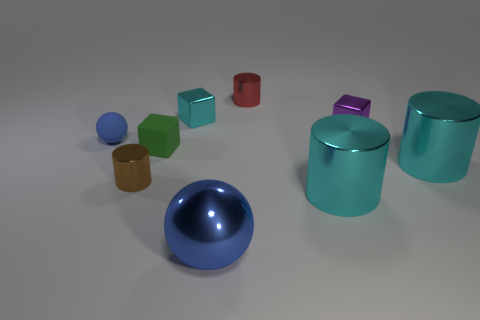Subtract all small brown cylinders. How many cylinders are left? 3 Subtract all cyan cylinders. How many cylinders are left? 2 Subtract all cylinders. How many objects are left? 5 Subtract 1 cylinders. How many cylinders are left? 3 Subtract all gray balls. Subtract all red blocks. How many balls are left? 2 Subtract all cyan spheres. How many red cylinders are left? 1 Subtract all matte balls. Subtract all brown objects. How many objects are left? 7 Add 4 metallic cylinders. How many metallic cylinders are left? 8 Add 4 tiny brown metal objects. How many tiny brown metal objects exist? 5 Subtract 0 purple spheres. How many objects are left? 9 